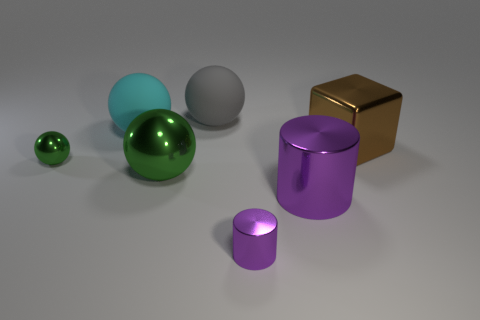There is a big shiny cylinder; does it have the same color as the matte sphere in front of the gray object?
Make the answer very short. No. What number of other big shiny blocks have the same color as the big block?
Your response must be concise. 0. There is a green object that is to the left of the sphere in front of the tiny green metal object; what is its size?
Offer a terse response. Small. What number of objects are either things to the left of the large brown metal cube or big purple metallic things?
Your answer should be compact. 6. Are there any cyan rubber spheres of the same size as the brown block?
Your answer should be compact. Yes. Are there any purple cylinders that are on the left side of the large rubber object in front of the gray rubber sphere?
Keep it short and to the point. No. How many cylinders are metallic things or small green things?
Offer a terse response. 2. Are there any brown metal objects of the same shape as the gray matte object?
Your answer should be compact. No. What is the shape of the tiny purple object?
Provide a succinct answer. Cylinder. How many things are either green metallic spheres or matte balls?
Make the answer very short. 4. 